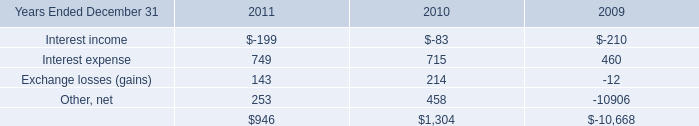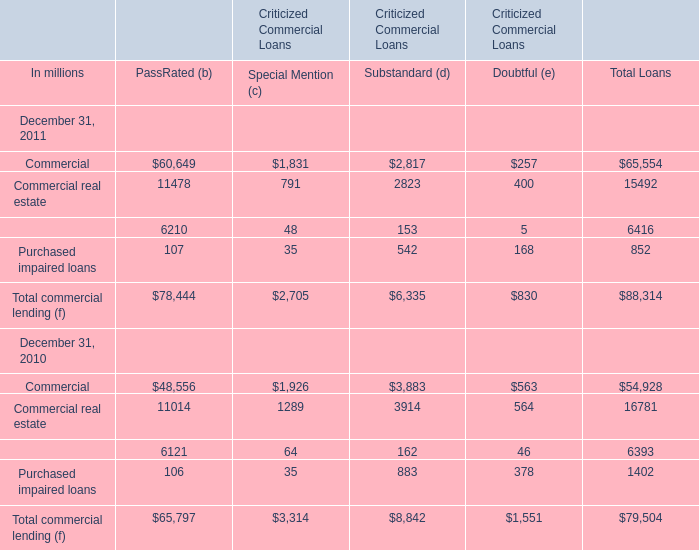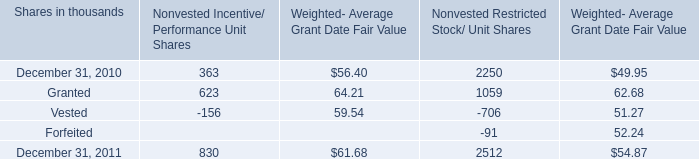What's the average of PassRated (b) in 2011? (in million) 
Computations: (78444 / 4)
Answer: 19611.0. 